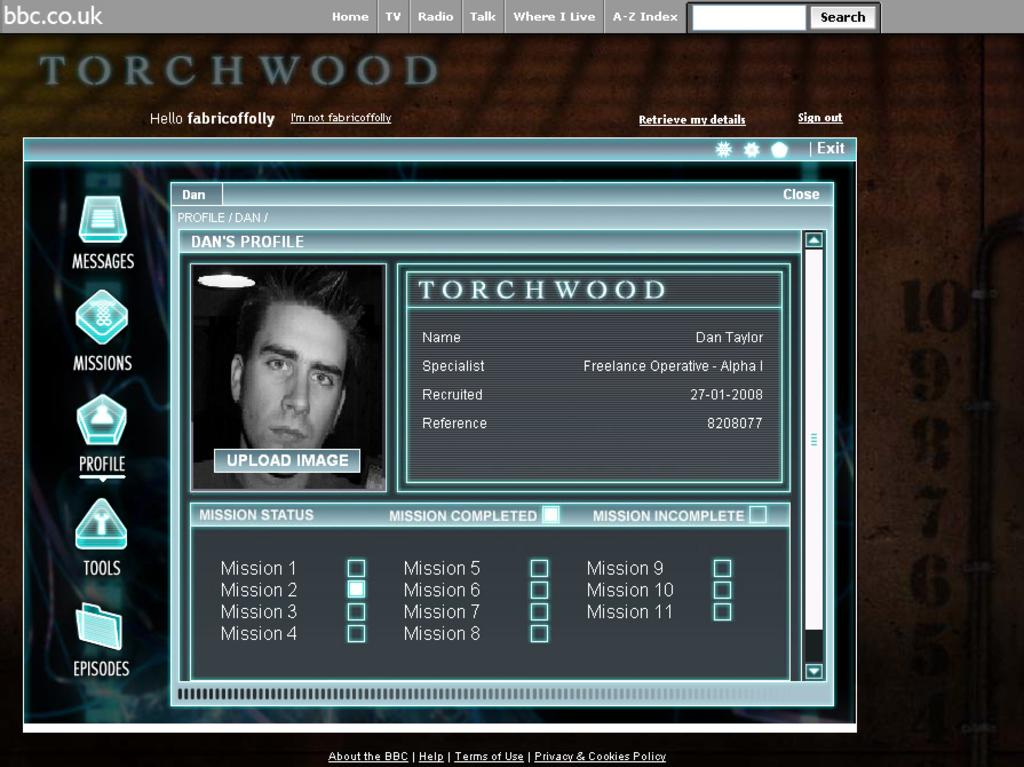What type of image is shown in the screenshot? The image is a screenshot. What can be found at the top of the screenshot? There is a menu bar at the top of the screenshot. What is the main subject of the screenshot? There is an image of a person in the center of the screenshot. Are there any words or phrases written in the screenshot? Some text is written in the screenshot. What can be found on the left side of the screenshot? There are icons on the left side of the screenshot. What type of ear is visible in the screenshot? There is no ear visible in the screenshot; it features an image of a person and other elements, but not an ear. What type of yam is being prepared in the screenshot? There is no yam or any food preparation visible in the screenshot. 